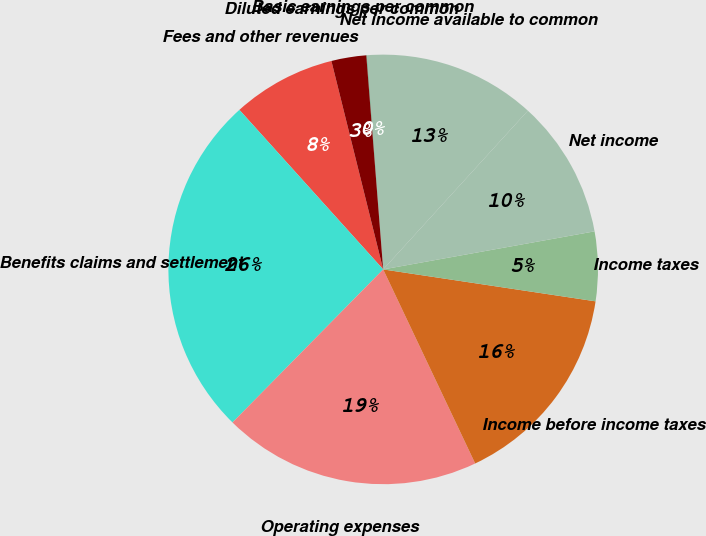Convert chart to OTSL. <chart><loc_0><loc_0><loc_500><loc_500><pie_chart><fcel>Fees and other revenues<fcel>Benefits claims and settlement<fcel>Operating expenses<fcel>Income before income taxes<fcel>Income taxes<fcel>Net income<fcel>Net income available to common<fcel>Basic earnings per common<fcel>Diluted earnings per common<nl><fcel>7.8%<fcel>25.95%<fcel>19.42%<fcel>15.58%<fcel>5.21%<fcel>10.4%<fcel>12.99%<fcel>0.03%<fcel>2.62%<nl></chart> 